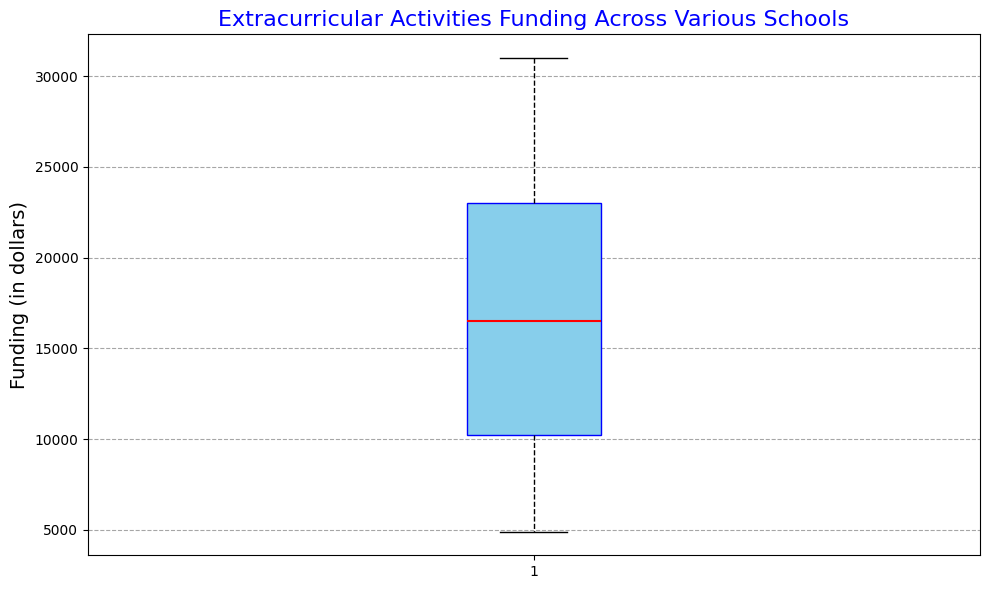What is the median funding for extracurricular activities across the schools? The median is represented by the red line within the box of the box plot. Look at the position of this red line relative to the y-axis to find the median funding amount.
Answer: 17000 Which school has the minimum funding for extracurricular activities, and what is it? The minimum funding amount is identified by the lower whisker on the box plot. The value at the end of this whisker represents the minimum funding.
Answer: School W, 4900 What is the interquartile range (IQR) for the extracurricular activities funding? The IQR is the range between the first quartile (Q1) and the third quartile (Q3). This can be seen by looking at the lower and upper edges of the box.
Answer: 13000 How many schools have funding below the first quartile? The first quartile represents the 25th percentile of the data. Count the number of data points below this value to determine how many schools have funding below the first quartile.
Answer: 6 Compare the funding of the school with the highest funding to the school with the lowest funding. What is the difference in their funding amounts? Identify the highest funding by looking at the top whisker and the lowest funding by looking at the bottom whisker. Subtract the minimum funding amount from the maximum funding amount for the difference.
Answer: 26100 Which range contains the most variability in funding allocations, the upper quartile or the lower quartile? Variability can be assessed based on the length of the whiskers or the box's height. Compare the heights of these visual elements between the upper and lower quartile ranges.
Answer: Lower quartile Is the distribution of extracurricular funding more positively skewed, negatively skewed, or symmetrical? Determine the skewness by observing the relative lengths of the whiskers and position of the median within the box. If one whisker is longer and the median is closer to one edge of the box, it indicates skewness.
Answer: Positively skewed What proportion of schools have funding between the first quartile (Q1) and the third quartile (Q3)? The box plot's box represents the interquartile range (IQR), which contains 50% of the data.
Answer: 50% 